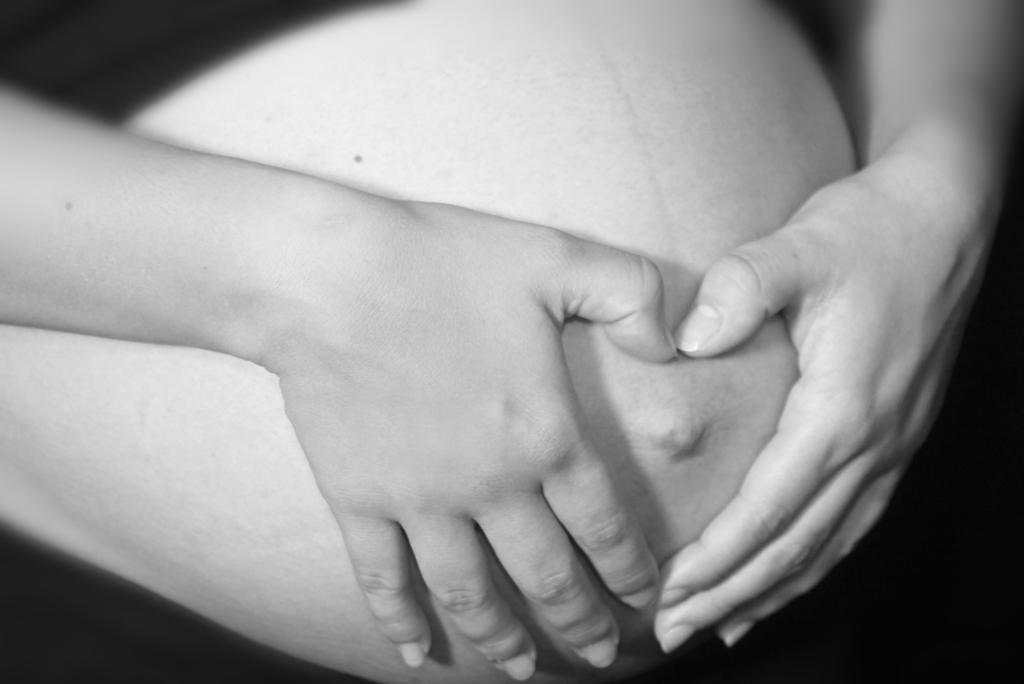In one or two sentences, can you explain what this image depicts? In this image we can see a person touching belly with the hands. 